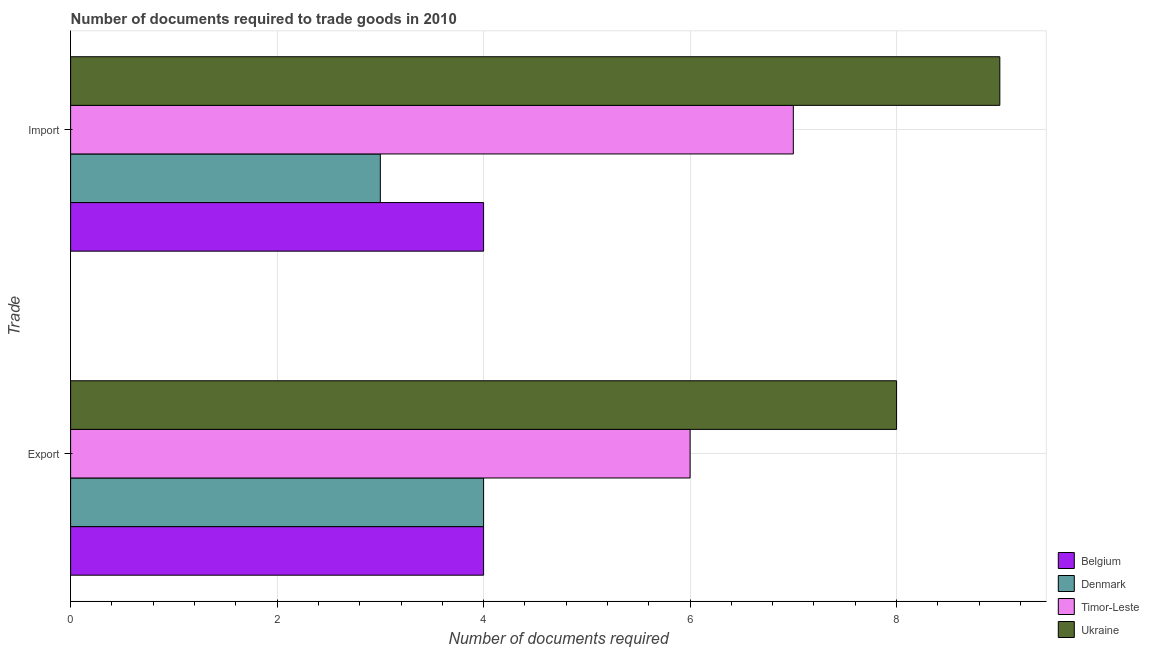How many groups of bars are there?
Your answer should be compact. 2. Are the number of bars per tick equal to the number of legend labels?
Give a very brief answer. Yes. How many bars are there on the 1st tick from the bottom?
Your response must be concise. 4. What is the label of the 2nd group of bars from the top?
Your answer should be compact. Export. What is the number of documents required to import goods in Ukraine?
Keep it short and to the point. 9. Across all countries, what is the maximum number of documents required to export goods?
Your answer should be very brief. 8. Across all countries, what is the minimum number of documents required to export goods?
Make the answer very short. 4. In which country was the number of documents required to import goods maximum?
Offer a terse response. Ukraine. What is the total number of documents required to export goods in the graph?
Provide a succinct answer. 22. What is the difference between the number of documents required to export goods in Belgium and that in Timor-Leste?
Your response must be concise. -2. What is the difference between the number of documents required to export goods in Belgium and the number of documents required to import goods in Ukraine?
Give a very brief answer. -5. What is the average number of documents required to import goods per country?
Provide a succinct answer. 5.75. What is the difference between the number of documents required to export goods and number of documents required to import goods in Denmark?
Provide a short and direct response. 1. In how many countries, is the number of documents required to export goods greater than 8 ?
Make the answer very short. 0. What is the ratio of the number of documents required to import goods in Belgium to that in Denmark?
Offer a very short reply. 1.33. What does the 2nd bar from the bottom in Export represents?
Give a very brief answer. Denmark. How many bars are there?
Provide a succinct answer. 8. Are the values on the major ticks of X-axis written in scientific E-notation?
Offer a very short reply. No. How many legend labels are there?
Provide a succinct answer. 4. How are the legend labels stacked?
Provide a short and direct response. Vertical. What is the title of the graph?
Offer a terse response. Number of documents required to trade goods in 2010. What is the label or title of the X-axis?
Make the answer very short. Number of documents required. What is the label or title of the Y-axis?
Offer a terse response. Trade. What is the Number of documents required in Belgium in Export?
Keep it short and to the point. 4. What is the Number of documents required in Timor-Leste in Export?
Keep it short and to the point. 6. What is the Number of documents required of Belgium in Import?
Your response must be concise. 4. What is the Number of documents required of Denmark in Import?
Your answer should be very brief. 3. What is the Number of documents required of Ukraine in Import?
Your answer should be compact. 9. Across all Trade, what is the maximum Number of documents required in Denmark?
Make the answer very short. 4. Across all Trade, what is the maximum Number of documents required of Ukraine?
Offer a terse response. 9. Across all Trade, what is the minimum Number of documents required of Timor-Leste?
Offer a terse response. 6. What is the total Number of documents required in Timor-Leste in the graph?
Give a very brief answer. 13. What is the total Number of documents required in Ukraine in the graph?
Provide a short and direct response. 17. What is the difference between the Number of documents required of Belgium in Export and the Number of documents required of Ukraine in Import?
Your answer should be compact. -5. What is the difference between the Number of documents required of Denmark in Export and the Number of documents required of Timor-Leste in Import?
Give a very brief answer. -3. What is the difference between the Number of documents required of Denmark in Export and the Number of documents required of Ukraine in Import?
Keep it short and to the point. -5. What is the average Number of documents required in Ukraine per Trade?
Ensure brevity in your answer.  8.5. What is the difference between the Number of documents required of Belgium and Number of documents required of Denmark in Export?
Your response must be concise. 0. What is the difference between the Number of documents required of Belgium and Number of documents required of Timor-Leste in Export?
Offer a very short reply. -2. What is the difference between the Number of documents required of Belgium and Number of documents required of Ukraine in Export?
Your answer should be very brief. -4. What is the difference between the Number of documents required in Denmark and Number of documents required in Ukraine in Export?
Provide a succinct answer. -4. What is the difference between the Number of documents required in Timor-Leste and Number of documents required in Ukraine in Export?
Your answer should be compact. -2. What is the difference between the Number of documents required in Belgium and Number of documents required in Denmark in Import?
Your answer should be very brief. 1. What is the difference between the Number of documents required in Belgium and Number of documents required in Timor-Leste in Import?
Provide a short and direct response. -3. What is the difference between the Number of documents required in Belgium and Number of documents required in Ukraine in Import?
Your answer should be compact. -5. What is the difference between the Number of documents required of Denmark and Number of documents required of Ukraine in Import?
Offer a very short reply. -6. What is the ratio of the Number of documents required of Timor-Leste in Export to that in Import?
Provide a short and direct response. 0.86. What is the ratio of the Number of documents required of Ukraine in Export to that in Import?
Give a very brief answer. 0.89. What is the difference between the highest and the second highest Number of documents required of Belgium?
Provide a succinct answer. 0. What is the difference between the highest and the lowest Number of documents required in Timor-Leste?
Ensure brevity in your answer.  1. What is the difference between the highest and the lowest Number of documents required in Ukraine?
Provide a short and direct response. 1. 